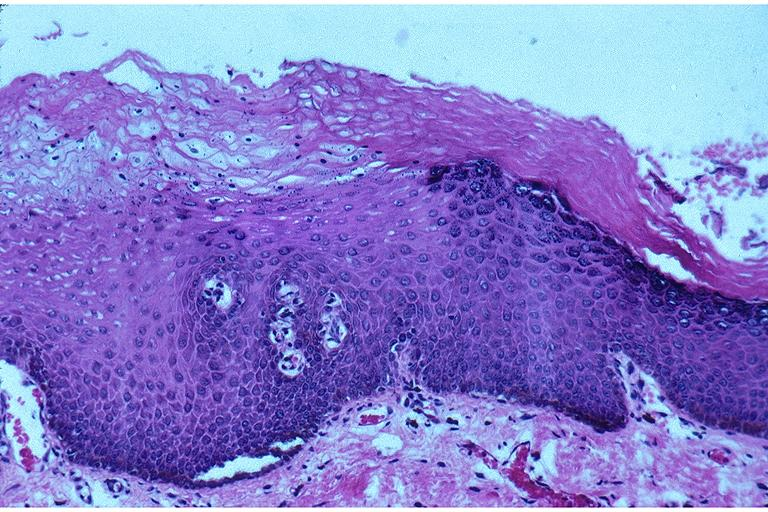does this image show epithelial hyperplasia and hyperkeratosis?
Answer the question using a single word or phrase. Yes 